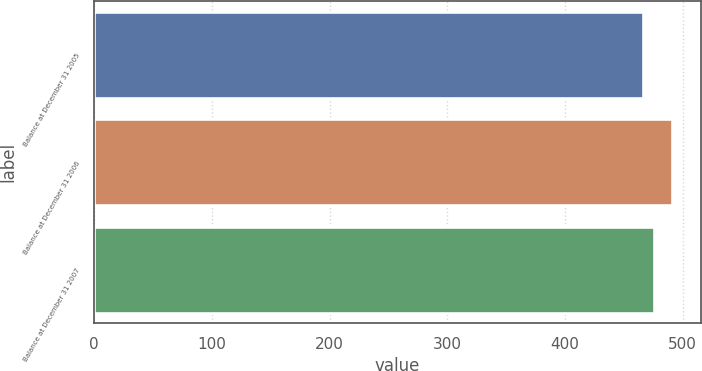Convert chart. <chart><loc_0><loc_0><loc_500><loc_500><bar_chart><fcel>Balance at December 31 2005<fcel>Balance at December 31 2006<fcel>Balance at December 31 2007<nl><fcel>466<fcel>491<fcel>476<nl></chart> 